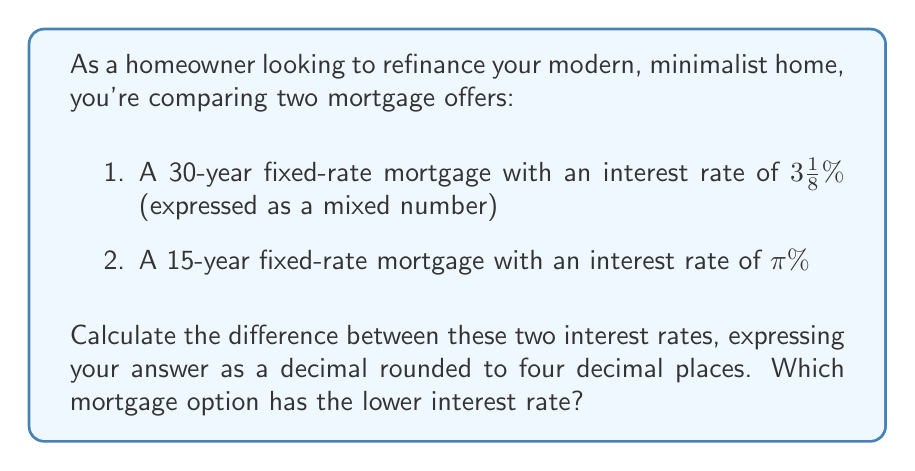What is the answer to this math problem? To compare these mortgage rates, we need to convert both to decimal form and then find their difference.

1. Converting $3\frac{1}{8}\%$ to a decimal:
   $$3\frac{1}{8} = 3.125\%$$

2. Converting $\pi\%$ to a decimal:
   $$\pi \approx 3.1415926535...\%$$

Now, let's find the difference:

$$\text{Difference} = \pi\% - 3.125\%$$
$$= 3.1415926535...\% - 3.125\%$$
$$= 0.0165926535...\%$$

Rounding to four decimal places:
$$0.0165926535... \approx 0.0166\%$$

To determine which mortgage has the lower interest rate, we compare the two rates:

$3.125\% < 3.1415926535...\%$

Therefore, the 30-year fixed-rate mortgage (3.125%) has the lower interest rate.
Answer: The difference between the two interest rates is 0.0166%. The 30-year fixed-rate mortgage has the lower interest rate at $3\frac{1}{8}\%$ (3.125%). 